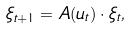<formula> <loc_0><loc_0><loc_500><loc_500>\xi _ { t + 1 } = A ( u _ { t } ) \cdot \xi _ { t } ,</formula> 